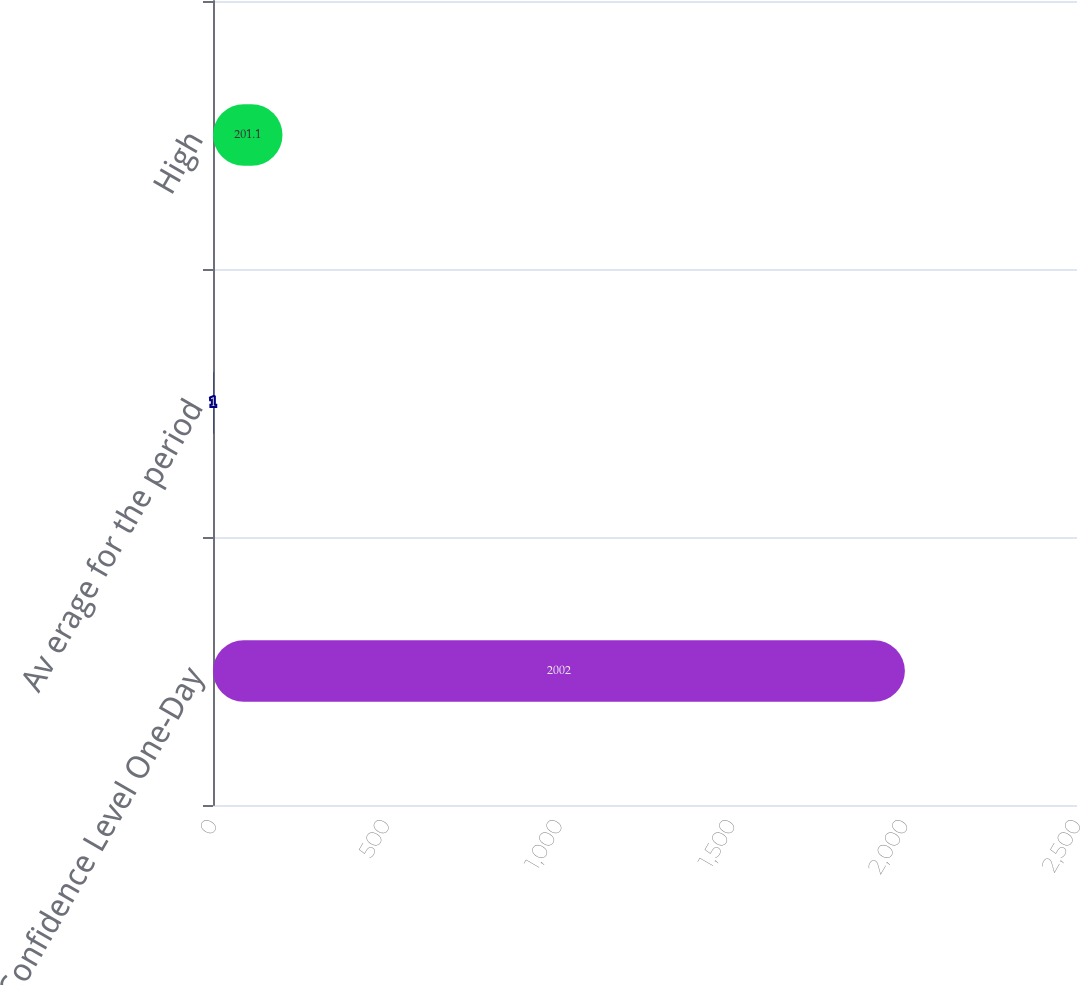<chart> <loc_0><loc_0><loc_500><loc_500><bar_chart><fcel>95 Confidence Level One-Day<fcel>Av erage for the period<fcel>High<nl><fcel>2002<fcel>1<fcel>201.1<nl></chart> 